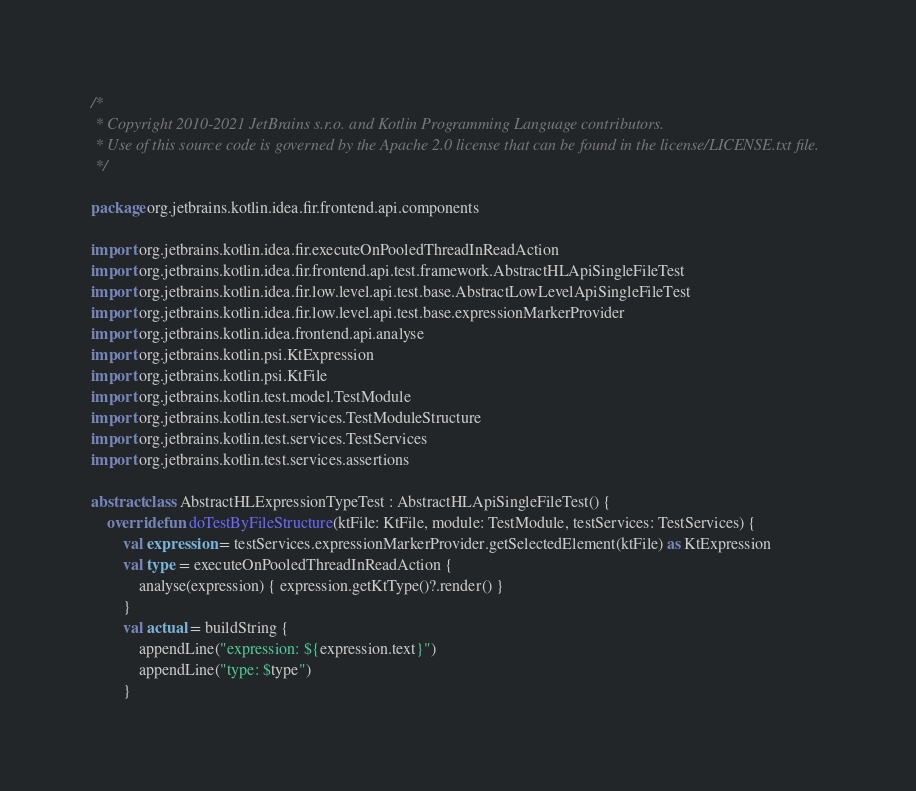Convert code to text. <code><loc_0><loc_0><loc_500><loc_500><_Kotlin_>/*
 * Copyright 2010-2021 JetBrains s.r.o. and Kotlin Programming Language contributors.
 * Use of this source code is governed by the Apache 2.0 license that can be found in the license/LICENSE.txt file.
 */

package org.jetbrains.kotlin.idea.fir.frontend.api.components

import org.jetbrains.kotlin.idea.fir.executeOnPooledThreadInReadAction
import org.jetbrains.kotlin.idea.fir.frontend.api.test.framework.AbstractHLApiSingleFileTest
import org.jetbrains.kotlin.idea.fir.low.level.api.test.base.AbstractLowLevelApiSingleFileTest
import org.jetbrains.kotlin.idea.fir.low.level.api.test.base.expressionMarkerProvider
import org.jetbrains.kotlin.idea.frontend.api.analyse
import org.jetbrains.kotlin.psi.KtExpression
import org.jetbrains.kotlin.psi.KtFile
import org.jetbrains.kotlin.test.model.TestModule
import org.jetbrains.kotlin.test.services.TestModuleStructure
import org.jetbrains.kotlin.test.services.TestServices
import org.jetbrains.kotlin.test.services.assertions

abstract class AbstractHLExpressionTypeTest : AbstractHLApiSingleFileTest() {
    override fun doTestByFileStructure(ktFile: KtFile, module: TestModule, testServices: TestServices) {
        val expression = testServices.expressionMarkerProvider.getSelectedElement(ktFile) as KtExpression
        val type = executeOnPooledThreadInReadAction {
            analyse(expression) { expression.getKtType()?.render() }
        }
        val actual = buildString {
            appendLine("expression: ${expression.text}")
            appendLine("type: $type")
        }</code> 